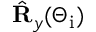Convert formula to latex. <formula><loc_0><loc_0><loc_500><loc_500>\hat { R } _ { y } ( \Theta _ { i } )</formula> 